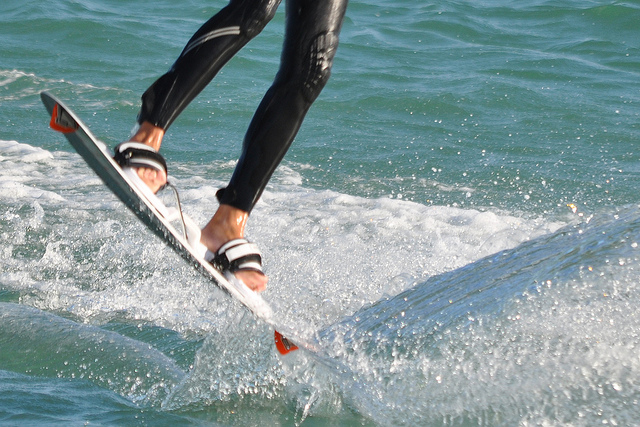Describe the environment depicted in the image. The image captures a lively aquatic scene, with sparkling water reflecting sunlight and generating a multitude of bubbles and splashes, indicating active water movement and outdoor recreation. Is it a safe environment for such activities? Based on the clarity of the water and the absence of visible hazards, it appears to be a safe environment for water sports. 